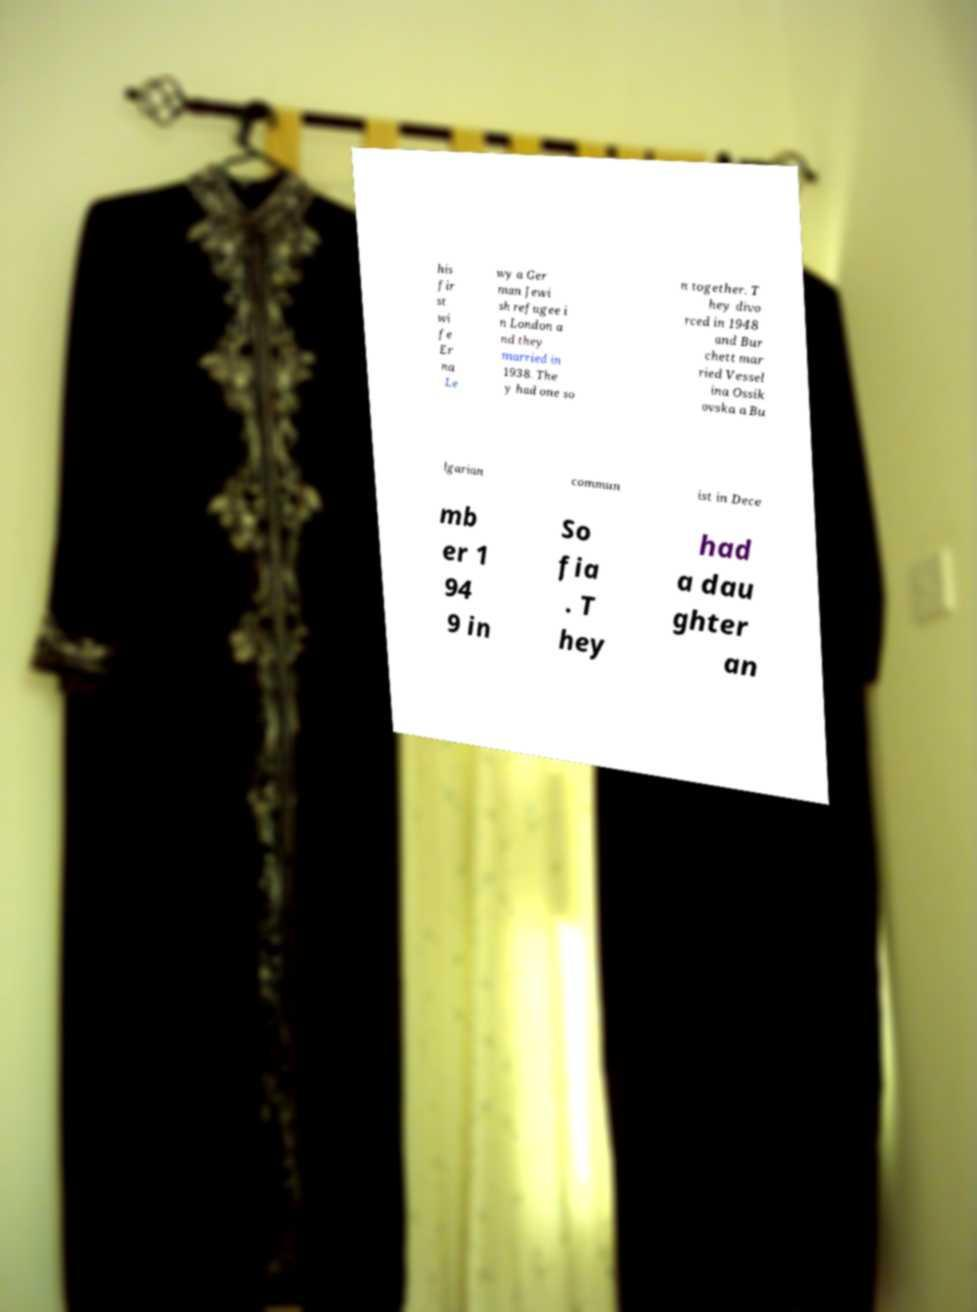Please identify and transcribe the text found in this image. his fir st wi fe Er na Le wy a Ger man Jewi sh refugee i n London a nd they married in 1938. The y had one so n together. T hey divo rced in 1948 and Bur chett mar ried Vessel ina Ossik ovska a Bu lgarian commun ist in Dece mb er 1 94 9 in So fia . T hey had a dau ghter an 